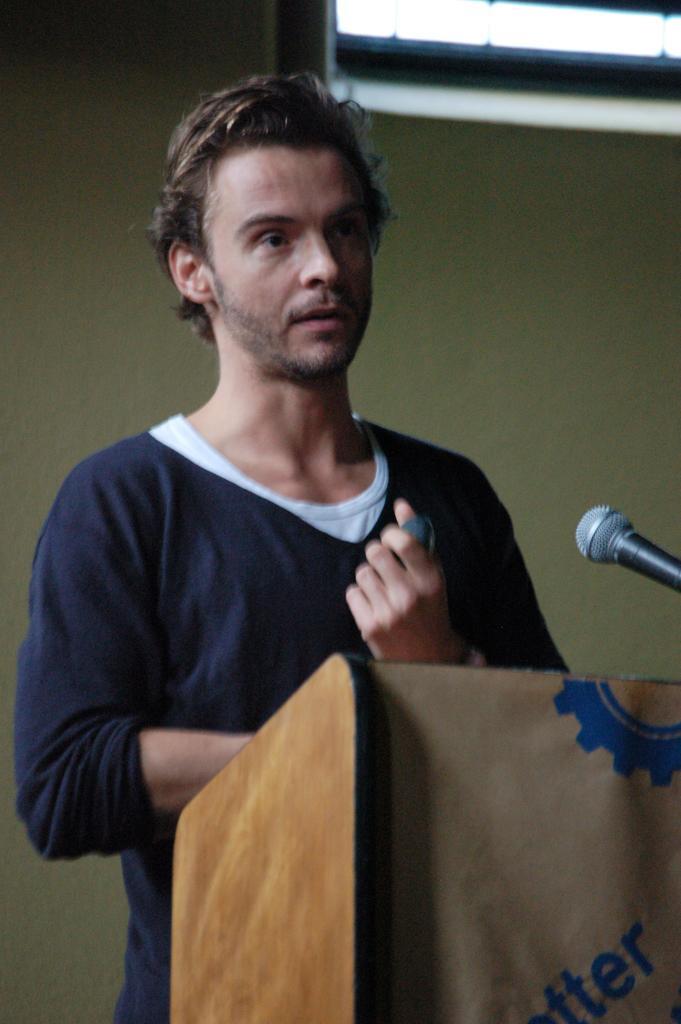How would you summarize this image in a sentence or two? In this picture there is a man standing behind the podium. There is a microphone on the podium. At the back there is a screen and there is a wall. 